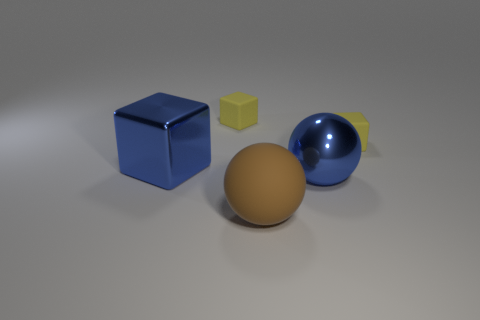Is the color of the big metallic block the same as the metal sphere?
Offer a terse response. Yes. Do the large blue object that is to the left of the rubber sphere and the large brown object have the same material?
Offer a terse response. No. Is there a shiny object that has the same color as the metallic sphere?
Your response must be concise. Yes. What size is the object that is both on the right side of the blue metallic cube and to the left of the large rubber thing?
Keep it short and to the point. Small. There is a large blue thing to the right of the brown object; what is its shape?
Your response must be concise. Sphere. Is the brown ball made of the same material as the small yellow thing that is on the right side of the brown sphere?
Your answer should be very brief. Yes. What material is the other large thing that is the same shape as the brown rubber thing?
Give a very brief answer. Metal. The matte thing that is both on the left side of the large blue metal sphere and behind the large brown rubber ball is what color?
Your answer should be compact. Yellow. What is the color of the big metallic block?
Your answer should be very brief. Blue. There is a thing that is the same color as the shiny ball; what material is it?
Provide a short and direct response. Metal. 